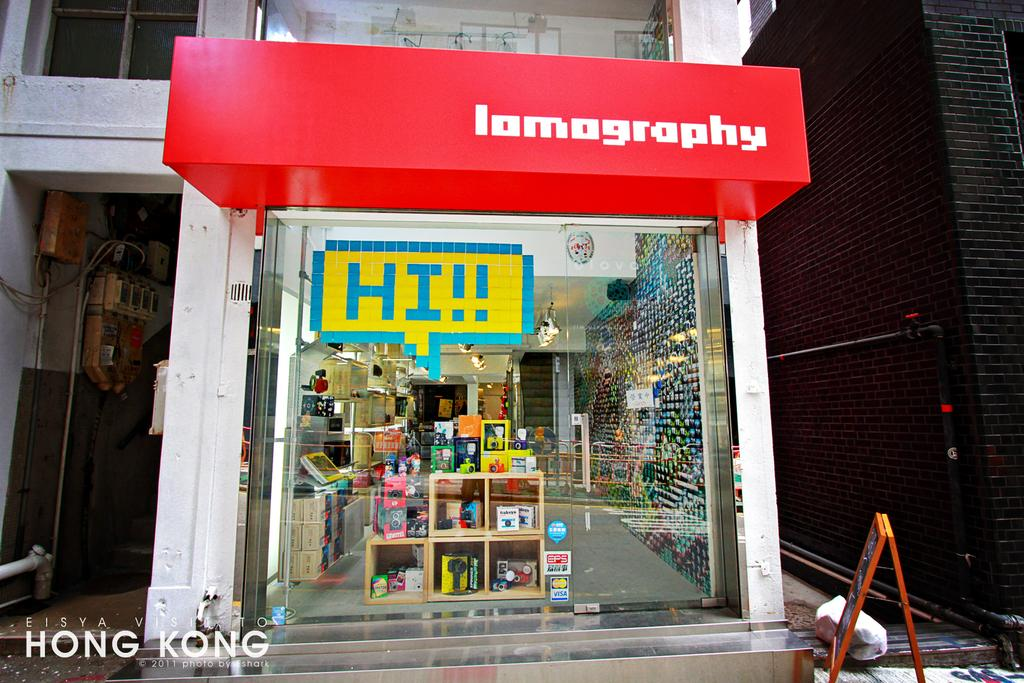<image>
Share a concise interpretation of the image provided. HI!! reads a sign hanging from a Iomography store 